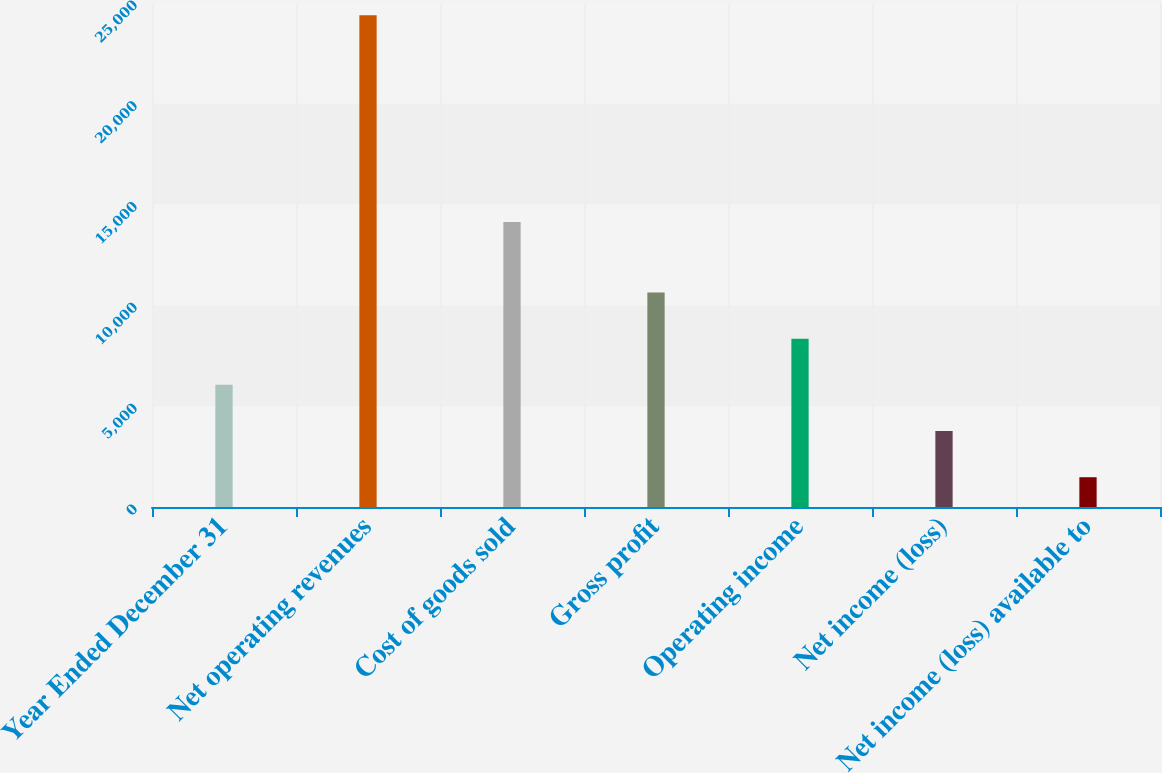Convert chart. <chart><loc_0><loc_0><loc_500><loc_500><bar_chart><fcel>Year Ended December 31<fcel>Net operating revenues<fcel>Cost of goods sold<fcel>Gross profit<fcel>Operating income<fcel>Net income (loss)<fcel>Net income (loss) available to<nl><fcel>6059.4<fcel>24389<fcel>14141<fcel>10641.8<fcel>8350.6<fcel>3768.2<fcel>1477<nl></chart> 